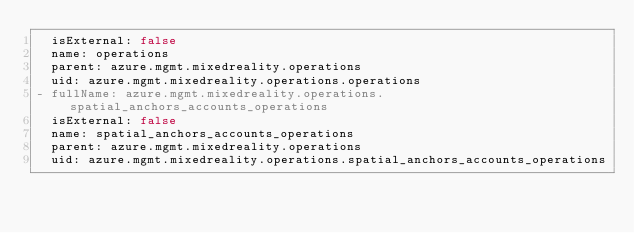<code> <loc_0><loc_0><loc_500><loc_500><_YAML_>  isExternal: false
  name: operations
  parent: azure.mgmt.mixedreality.operations
  uid: azure.mgmt.mixedreality.operations.operations
- fullName: azure.mgmt.mixedreality.operations.spatial_anchors_accounts_operations
  isExternal: false
  name: spatial_anchors_accounts_operations
  parent: azure.mgmt.mixedreality.operations
  uid: azure.mgmt.mixedreality.operations.spatial_anchors_accounts_operations
</code> 